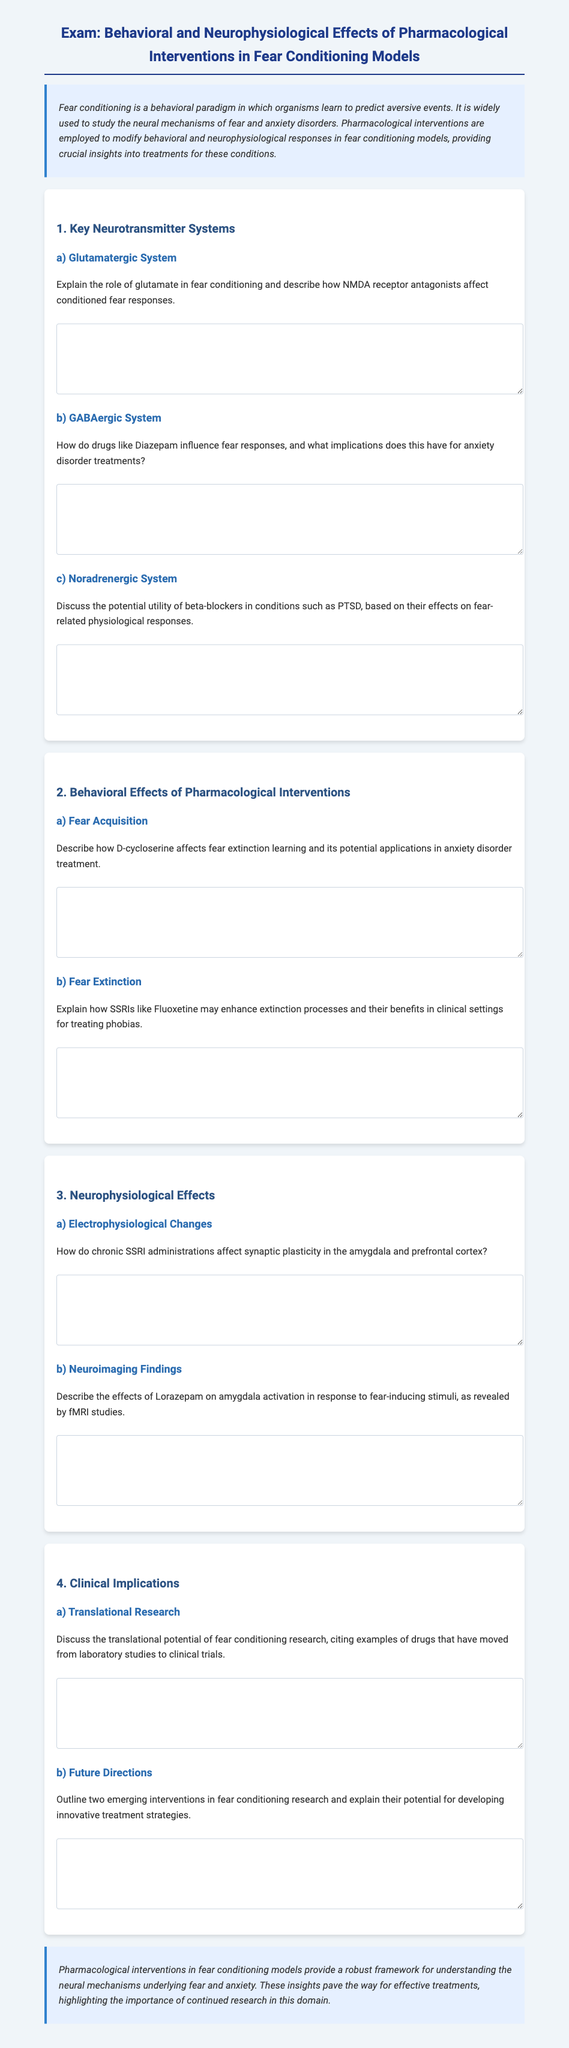What is the title of the exam? The title of the exam is provided at the top of the document, indicating the focus on pharmacological interventions in fear conditioning models.
Answer: Exam: Behavioral and Neurophysiological Effects of Pharmacological Interventions in Fear Conditioning Models What is a key neurotransmitter system involved in fear conditioning? The document lists several neurotransmitter systems involved in fear conditioning, including the glutamatergic system, GABAergic system, and noradrenergic system.
Answer: Glutamatergic System Which drug is mentioned as an example of a GABAergic drug? The document specifically mentions Diazepam as an example of a drug that influences fear responses.
Answer: Diazepam What is one effect of D-cycloserine noted in the exam? The document asks about D-cycloserine's effects on fear extinction learning and its applications in treatment.
Answer: Fear extinction learning What type of physiological changes do chronic SSRI administrations impact? The exam question focuses on chronic SSRI administrations and their effects, particularly on synaptic plasticity in specific brain regions.
Answer: Synaptic plasticity In what context is the anxiolytic Lorazepam discussed? The document discusses Lorazepam in relation to its effects on amygdala activation in response to fear-inducing stimuli.
Answer: Amygdala activation What are two examples of emerging interventions noted in the document? The document specifically asks for two emerging interventions in fear conditioning research and their potential treatment strategies.
Answer: Not specified in the document What is the purpose of pharmacological interventions in fear conditioning models? The document states that pharmacological interventions provide insights into behavioral and neurophysiological responses to fear conditioning.
Answer: Understanding neural mechanisms of fear and anxiety What is one clinical implication discussed in the exam? The document mentions translational potential of fear conditioning research, moving from laboratory studies to clinical trials.
Answer: Translational research What kind of behavioral effect does the exam investigate regarding SSRIs like Fluoxetine? The specific question targets how SSRIs may enhance extinction processes in dealing with phobias.
Answer: Enhance extinction processes 